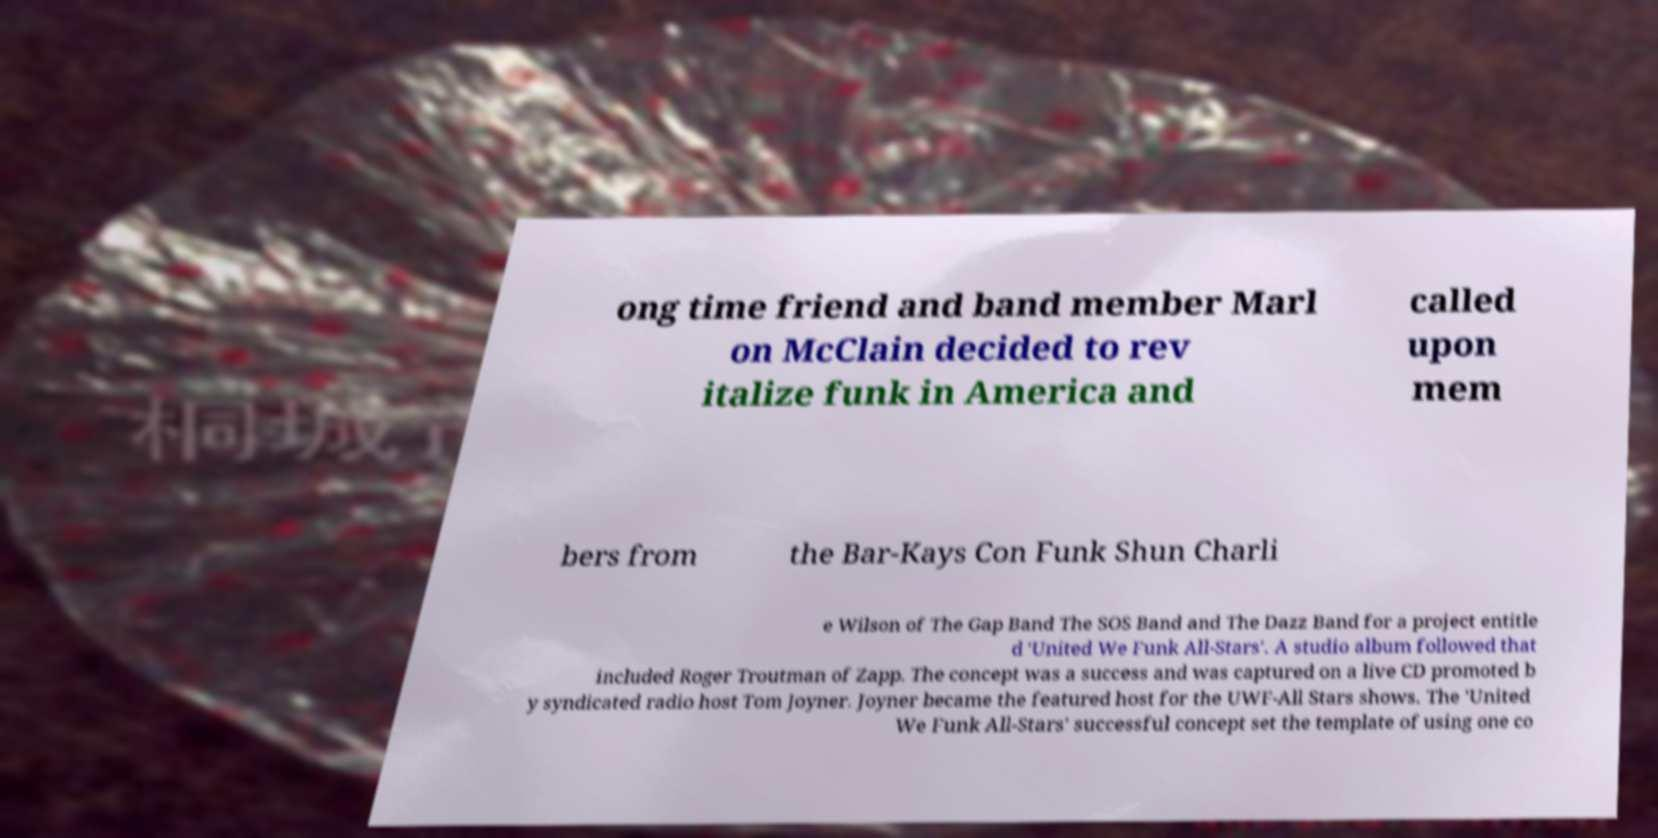Can you accurately transcribe the text from the provided image for me? ong time friend and band member Marl on McClain decided to rev italize funk in America and called upon mem bers from the Bar-Kays Con Funk Shun Charli e Wilson of The Gap Band The SOS Band and The Dazz Band for a project entitle d 'United We Funk All-Stars'. A studio album followed that included Roger Troutman of Zapp. The concept was a success and was captured on a live CD promoted b y syndicated radio host Tom Joyner. Joyner became the featured host for the UWF-All Stars shows. The 'United We Funk All-Stars' successful concept set the template of using one co 